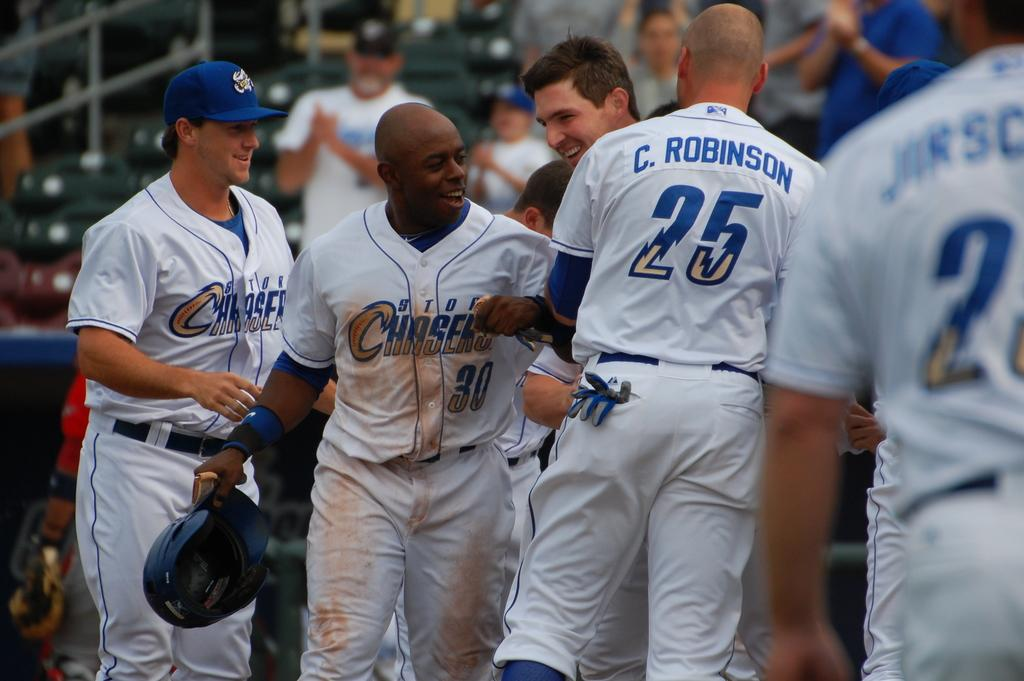<image>
Relay a brief, clear account of the picture shown. Baseball player in white uniform with Storm Chaser on the front. 